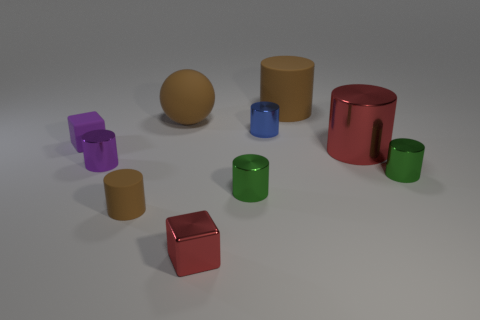How many brown blocks have the same size as the red metal block?
Give a very brief answer. 0. The metal cylinder that is the same color as the rubber block is what size?
Your response must be concise. Small. How many things are red blocks or tiny metal cylinders that are left of the blue object?
Offer a very short reply. 3. There is a metallic thing that is to the right of the blue cylinder and in front of the large metal cylinder; what color is it?
Keep it short and to the point. Green. Is the size of the red cube the same as the purple rubber block?
Your answer should be compact. Yes. What color is the shiny thing behind the big red cylinder?
Ensure brevity in your answer.  Blue. Is there a large shiny block that has the same color as the ball?
Keep it short and to the point. No. What color is the rubber block that is the same size as the metallic cube?
Keep it short and to the point. Purple. Do the purple rubber thing and the tiny blue object have the same shape?
Provide a succinct answer. No. There is a tiny object that is right of the blue cylinder; what is it made of?
Your response must be concise. Metal. 